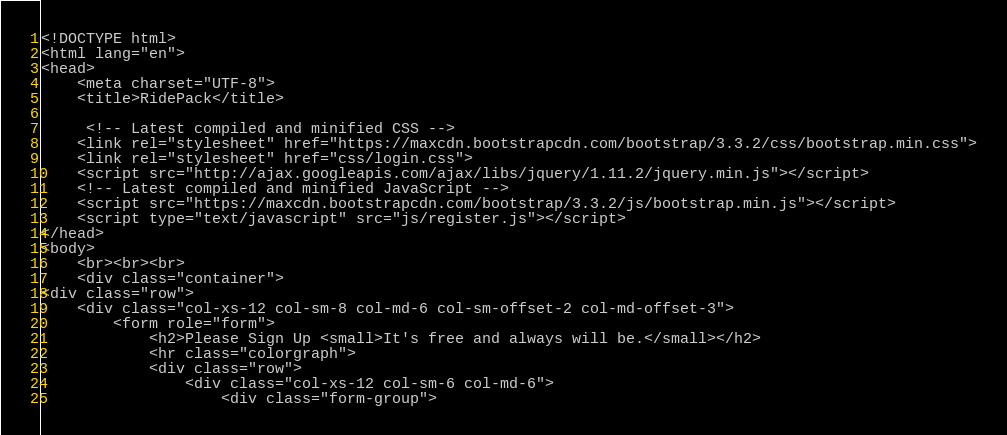Convert code to text. <code><loc_0><loc_0><loc_500><loc_500><_PHP_><!DOCTYPE html>
<html lang="en">
<head>
	<meta charset="UTF-8">
	<title>RidePack</title>

	 <!-- Latest compiled and minified CSS -->
    <link rel="stylesheet" href="https://maxcdn.bootstrapcdn.com/bootstrap/3.3.2/css/bootstrap.min.css">
	<link rel="stylesheet" href="css/login.css">
    <script src="http://ajax.googleapis.com/ajax/libs/jquery/1.11.2/jquery.min.js"></script>
    <!-- Latest compiled and minified JavaScript -->
    <script src="https://maxcdn.bootstrapcdn.com/bootstrap/3.3.2/js/bootstrap.min.js"></script>
    <script type="text/javascript" src="js/register.js"></script>
</head>
<body>
	<br><br><br>
	<div class="container">
<div class="row">
    <div class="col-xs-12 col-sm-8 col-md-6 col-sm-offset-2 col-md-offset-3">
		<form role="form">
			<h2>Please Sign Up <small>It's free and always will be.</small></h2>
			<hr class="colorgraph">
			<div class="row">
				<div class="col-xs-12 col-sm-6 col-md-6">
					<div class="form-group"></code> 